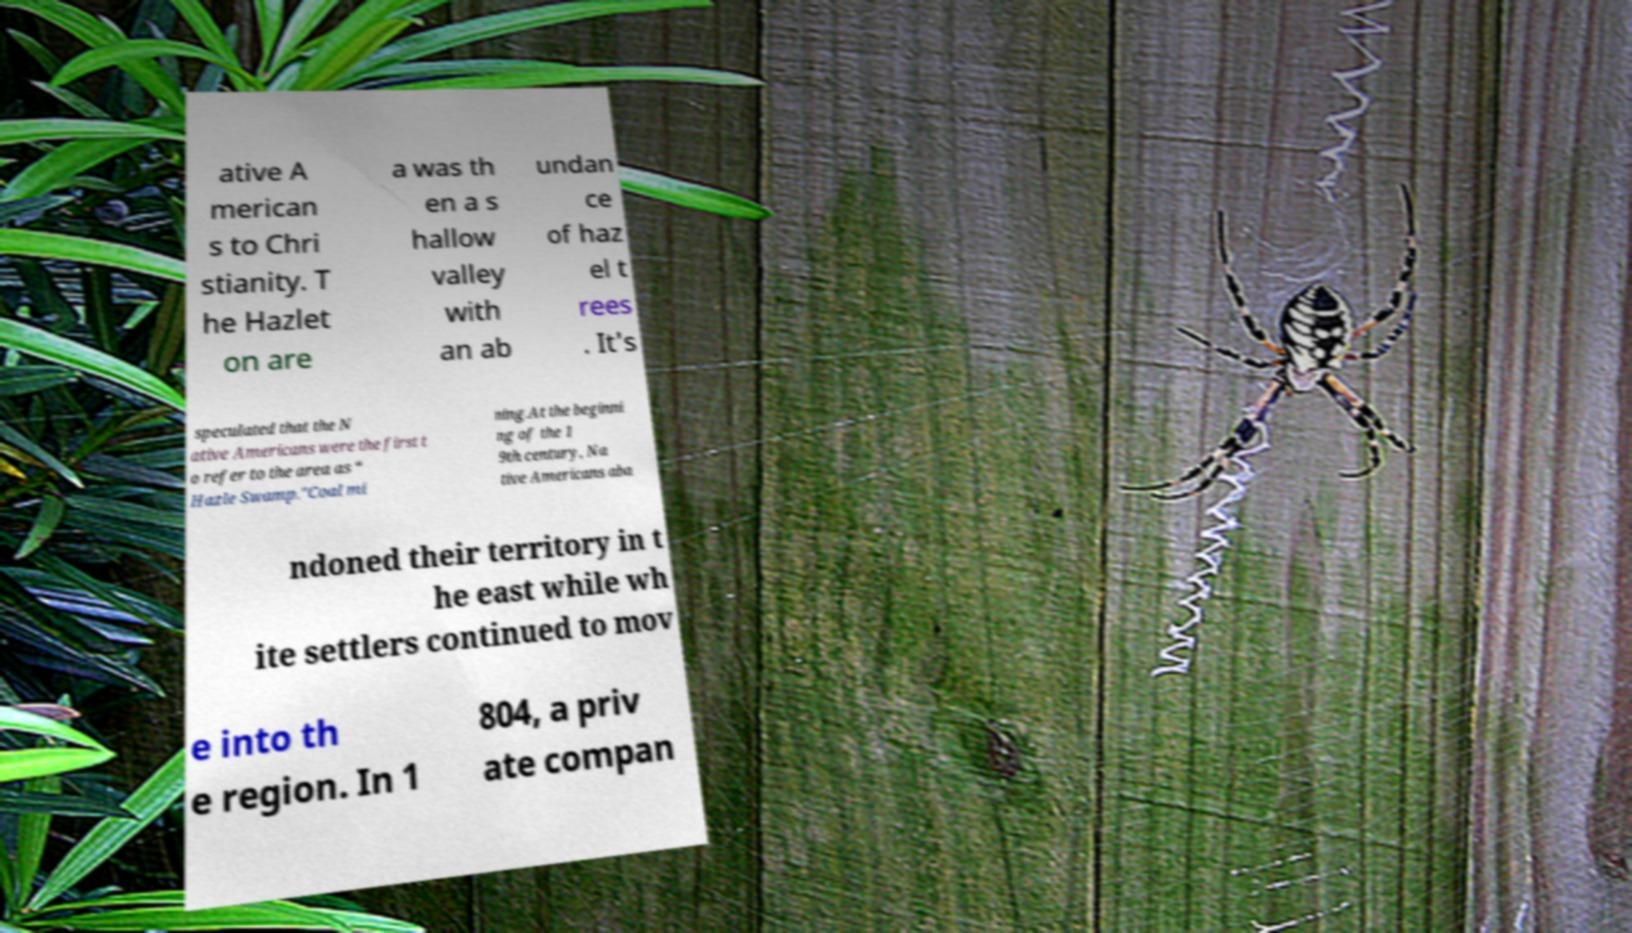There's text embedded in this image that I need extracted. Can you transcribe it verbatim? ative A merican s to Chri stianity. T he Hazlet on are a was th en a s hallow valley with an ab undan ce of haz el t rees . It's speculated that the N ative Americans were the first t o refer to the area as “ Hazle Swamp."Coal mi ning.At the beginni ng of the 1 9th century, Na tive Americans aba ndoned their territory in t he east while wh ite settlers continued to mov e into th e region. In 1 804, a priv ate compan 